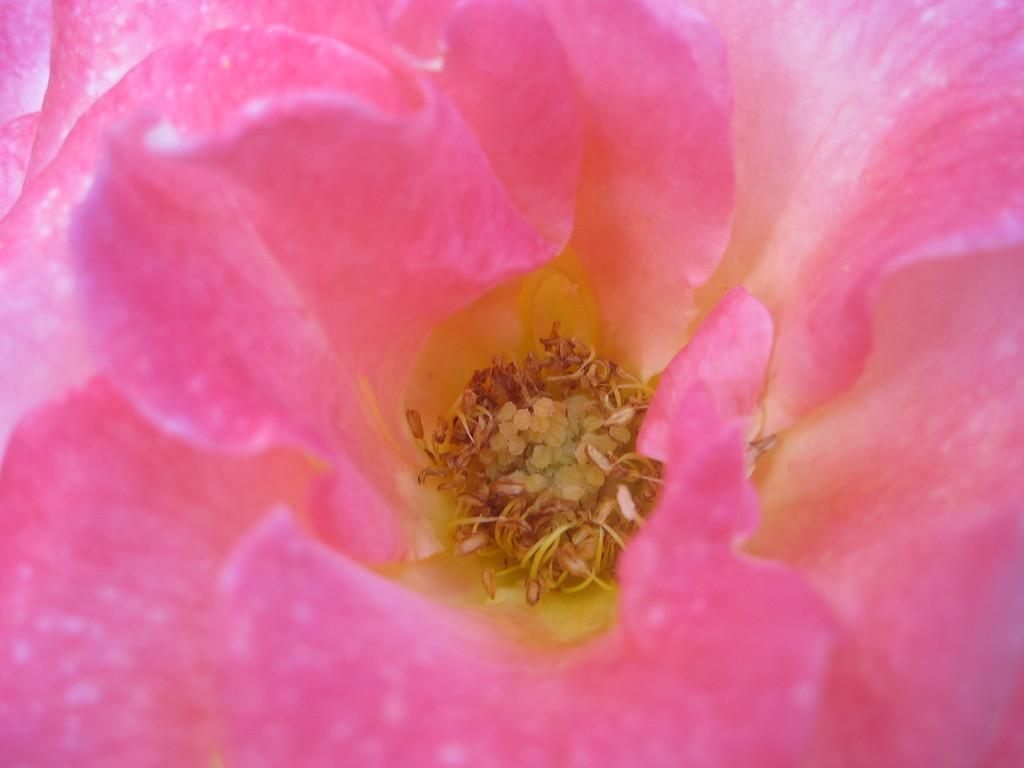What is the main subject of the image? There is a flower in the image. Can you describe the color of the flower? The flower is pink in color. What type of wine is being served in the image? There is no wine present in the image; it features a pink flower. How many cattle can be seen grazing in the image? There are no cattle present in the image; it features a pink flower. 